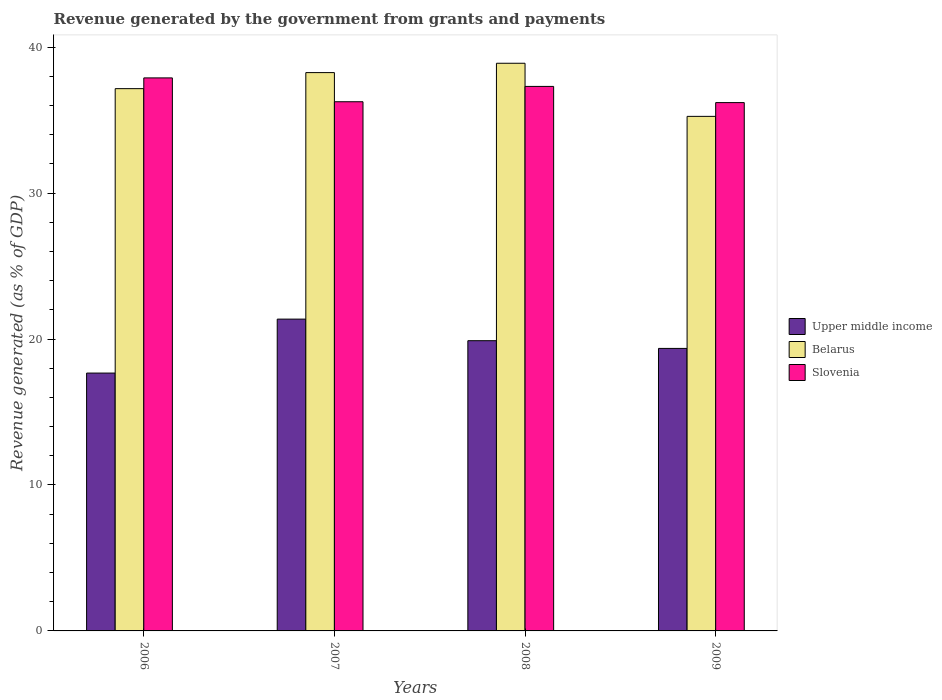Are the number of bars per tick equal to the number of legend labels?
Offer a terse response. Yes. How many bars are there on the 3rd tick from the left?
Offer a terse response. 3. In how many cases, is the number of bars for a given year not equal to the number of legend labels?
Provide a succinct answer. 0. What is the revenue generated by the government in Belarus in 2006?
Make the answer very short. 37.15. Across all years, what is the maximum revenue generated by the government in Belarus?
Ensure brevity in your answer.  38.89. Across all years, what is the minimum revenue generated by the government in Slovenia?
Offer a terse response. 36.2. In which year was the revenue generated by the government in Upper middle income maximum?
Offer a very short reply. 2007. In which year was the revenue generated by the government in Slovenia minimum?
Offer a terse response. 2009. What is the total revenue generated by the government in Upper middle income in the graph?
Offer a very short reply. 78.27. What is the difference between the revenue generated by the government in Upper middle income in 2006 and that in 2009?
Your answer should be compact. -1.69. What is the difference between the revenue generated by the government in Belarus in 2007 and the revenue generated by the government in Upper middle income in 2009?
Ensure brevity in your answer.  18.9. What is the average revenue generated by the government in Upper middle income per year?
Your answer should be very brief. 19.57. In the year 2006, what is the difference between the revenue generated by the government in Belarus and revenue generated by the government in Upper middle income?
Your response must be concise. 19.49. What is the ratio of the revenue generated by the government in Belarus in 2007 to that in 2008?
Give a very brief answer. 0.98. What is the difference between the highest and the second highest revenue generated by the government in Belarus?
Ensure brevity in your answer.  0.64. What is the difference between the highest and the lowest revenue generated by the government in Slovenia?
Offer a terse response. 1.69. Is the sum of the revenue generated by the government in Upper middle income in 2006 and 2009 greater than the maximum revenue generated by the government in Slovenia across all years?
Provide a succinct answer. No. What does the 3rd bar from the left in 2008 represents?
Provide a succinct answer. Slovenia. What does the 2nd bar from the right in 2006 represents?
Provide a short and direct response. Belarus. Is it the case that in every year, the sum of the revenue generated by the government in Upper middle income and revenue generated by the government in Slovenia is greater than the revenue generated by the government in Belarus?
Keep it short and to the point. Yes. How many bars are there?
Your answer should be very brief. 12. How many years are there in the graph?
Provide a succinct answer. 4. Does the graph contain any zero values?
Make the answer very short. No. Where does the legend appear in the graph?
Your answer should be compact. Center right. How many legend labels are there?
Make the answer very short. 3. How are the legend labels stacked?
Provide a succinct answer. Vertical. What is the title of the graph?
Provide a short and direct response. Revenue generated by the government from grants and payments. Does "Ethiopia" appear as one of the legend labels in the graph?
Offer a terse response. No. What is the label or title of the X-axis?
Give a very brief answer. Years. What is the label or title of the Y-axis?
Your answer should be compact. Revenue generated (as % of GDP). What is the Revenue generated (as % of GDP) in Upper middle income in 2006?
Provide a short and direct response. 17.67. What is the Revenue generated (as % of GDP) of Belarus in 2006?
Keep it short and to the point. 37.15. What is the Revenue generated (as % of GDP) of Slovenia in 2006?
Provide a succinct answer. 37.89. What is the Revenue generated (as % of GDP) of Upper middle income in 2007?
Offer a very short reply. 21.36. What is the Revenue generated (as % of GDP) of Belarus in 2007?
Your answer should be very brief. 38.25. What is the Revenue generated (as % of GDP) in Slovenia in 2007?
Offer a terse response. 36.25. What is the Revenue generated (as % of GDP) of Upper middle income in 2008?
Keep it short and to the point. 19.88. What is the Revenue generated (as % of GDP) in Belarus in 2008?
Your response must be concise. 38.89. What is the Revenue generated (as % of GDP) of Slovenia in 2008?
Your response must be concise. 37.31. What is the Revenue generated (as % of GDP) in Upper middle income in 2009?
Provide a succinct answer. 19.35. What is the Revenue generated (as % of GDP) of Belarus in 2009?
Offer a terse response. 35.25. What is the Revenue generated (as % of GDP) in Slovenia in 2009?
Your answer should be very brief. 36.2. Across all years, what is the maximum Revenue generated (as % of GDP) in Upper middle income?
Your response must be concise. 21.36. Across all years, what is the maximum Revenue generated (as % of GDP) in Belarus?
Ensure brevity in your answer.  38.89. Across all years, what is the maximum Revenue generated (as % of GDP) of Slovenia?
Provide a short and direct response. 37.89. Across all years, what is the minimum Revenue generated (as % of GDP) in Upper middle income?
Your answer should be compact. 17.67. Across all years, what is the minimum Revenue generated (as % of GDP) of Belarus?
Keep it short and to the point. 35.25. Across all years, what is the minimum Revenue generated (as % of GDP) of Slovenia?
Your answer should be compact. 36.2. What is the total Revenue generated (as % of GDP) of Upper middle income in the graph?
Keep it short and to the point. 78.27. What is the total Revenue generated (as % of GDP) in Belarus in the graph?
Provide a short and direct response. 149.55. What is the total Revenue generated (as % of GDP) of Slovenia in the graph?
Your answer should be compact. 147.64. What is the difference between the Revenue generated (as % of GDP) of Upper middle income in 2006 and that in 2007?
Provide a succinct answer. -3.7. What is the difference between the Revenue generated (as % of GDP) of Belarus in 2006 and that in 2007?
Your answer should be very brief. -1.1. What is the difference between the Revenue generated (as % of GDP) in Slovenia in 2006 and that in 2007?
Provide a short and direct response. 1.63. What is the difference between the Revenue generated (as % of GDP) in Upper middle income in 2006 and that in 2008?
Ensure brevity in your answer.  -2.22. What is the difference between the Revenue generated (as % of GDP) of Belarus in 2006 and that in 2008?
Offer a very short reply. -1.74. What is the difference between the Revenue generated (as % of GDP) of Slovenia in 2006 and that in 2008?
Keep it short and to the point. 0.58. What is the difference between the Revenue generated (as % of GDP) of Upper middle income in 2006 and that in 2009?
Provide a short and direct response. -1.69. What is the difference between the Revenue generated (as % of GDP) in Belarus in 2006 and that in 2009?
Your answer should be compact. 1.9. What is the difference between the Revenue generated (as % of GDP) in Slovenia in 2006 and that in 2009?
Your answer should be compact. 1.69. What is the difference between the Revenue generated (as % of GDP) in Upper middle income in 2007 and that in 2008?
Your answer should be compact. 1.48. What is the difference between the Revenue generated (as % of GDP) in Belarus in 2007 and that in 2008?
Your response must be concise. -0.64. What is the difference between the Revenue generated (as % of GDP) of Slovenia in 2007 and that in 2008?
Offer a very short reply. -1.05. What is the difference between the Revenue generated (as % of GDP) of Upper middle income in 2007 and that in 2009?
Your answer should be compact. 2.01. What is the difference between the Revenue generated (as % of GDP) of Belarus in 2007 and that in 2009?
Your answer should be compact. 3. What is the difference between the Revenue generated (as % of GDP) of Slovenia in 2007 and that in 2009?
Give a very brief answer. 0.06. What is the difference between the Revenue generated (as % of GDP) of Upper middle income in 2008 and that in 2009?
Your response must be concise. 0.53. What is the difference between the Revenue generated (as % of GDP) of Belarus in 2008 and that in 2009?
Keep it short and to the point. 3.64. What is the difference between the Revenue generated (as % of GDP) of Slovenia in 2008 and that in 2009?
Give a very brief answer. 1.11. What is the difference between the Revenue generated (as % of GDP) of Upper middle income in 2006 and the Revenue generated (as % of GDP) of Belarus in 2007?
Ensure brevity in your answer.  -20.59. What is the difference between the Revenue generated (as % of GDP) in Upper middle income in 2006 and the Revenue generated (as % of GDP) in Slovenia in 2007?
Offer a very short reply. -18.59. What is the difference between the Revenue generated (as % of GDP) in Belarus in 2006 and the Revenue generated (as % of GDP) in Slovenia in 2007?
Provide a short and direct response. 0.9. What is the difference between the Revenue generated (as % of GDP) of Upper middle income in 2006 and the Revenue generated (as % of GDP) of Belarus in 2008?
Provide a short and direct response. -21.23. What is the difference between the Revenue generated (as % of GDP) in Upper middle income in 2006 and the Revenue generated (as % of GDP) in Slovenia in 2008?
Offer a terse response. -19.64. What is the difference between the Revenue generated (as % of GDP) of Belarus in 2006 and the Revenue generated (as % of GDP) of Slovenia in 2008?
Your answer should be compact. -0.15. What is the difference between the Revenue generated (as % of GDP) of Upper middle income in 2006 and the Revenue generated (as % of GDP) of Belarus in 2009?
Offer a terse response. -17.59. What is the difference between the Revenue generated (as % of GDP) in Upper middle income in 2006 and the Revenue generated (as % of GDP) in Slovenia in 2009?
Provide a short and direct response. -18.53. What is the difference between the Revenue generated (as % of GDP) in Belarus in 2006 and the Revenue generated (as % of GDP) in Slovenia in 2009?
Provide a short and direct response. 0.96. What is the difference between the Revenue generated (as % of GDP) in Upper middle income in 2007 and the Revenue generated (as % of GDP) in Belarus in 2008?
Provide a succinct answer. -17.53. What is the difference between the Revenue generated (as % of GDP) of Upper middle income in 2007 and the Revenue generated (as % of GDP) of Slovenia in 2008?
Keep it short and to the point. -15.94. What is the difference between the Revenue generated (as % of GDP) in Belarus in 2007 and the Revenue generated (as % of GDP) in Slovenia in 2008?
Ensure brevity in your answer.  0.95. What is the difference between the Revenue generated (as % of GDP) of Upper middle income in 2007 and the Revenue generated (as % of GDP) of Belarus in 2009?
Ensure brevity in your answer.  -13.89. What is the difference between the Revenue generated (as % of GDP) in Upper middle income in 2007 and the Revenue generated (as % of GDP) in Slovenia in 2009?
Provide a short and direct response. -14.83. What is the difference between the Revenue generated (as % of GDP) of Belarus in 2007 and the Revenue generated (as % of GDP) of Slovenia in 2009?
Your answer should be very brief. 2.06. What is the difference between the Revenue generated (as % of GDP) of Upper middle income in 2008 and the Revenue generated (as % of GDP) of Belarus in 2009?
Offer a very short reply. -15.37. What is the difference between the Revenue generated (as % of GDP) of Upper middle income in 2008 and the Revenue generated (as % of GDP) of Slovenia in 2009?
Your answer should be compact. -16.31. What is the difference between the Revenue generated (as % of GDP) of Belarus in 2008 and the Revenue generated (as % of GDP) of Slovenia in 2009?
Make the answer very short. 2.7. What is the average Revenue generated (as % of GDP) of Upper middle income per year?
Offer a very short reply. 19.57. What is the average Revenue generated (as % of GDP) of Belarus per year?
Keep it short and to the point. 37.39. What is the average Revenue generated (as % of GDP) in Slovenia per year?
Offer a terse response. 36.91. In the year 2006, what is the difference between the Revenue generated (as % of GDP) in Upper middle income and Revenue generated (as % of GDP) in Belarus?
Provide a succinct answer. -19.49. In the year 2006, what is the difference between the Revenue generated (as % of GDP) in Upper middle income and Revenue generated (as % of GDP) in Slovenia?
Provide a succinct answer. -20.22. In the year 2006, what is the difference between the Revenue generated (as % of GDP) in Belarus and Revenue generated (as % of GDP) in Slovenia?
Offer a terse response. -0.74. In the year 2007, what is the difference between the Revenue generated (as % of GDP) in Upper middle income and Revenue generated (as % of GDP) in Belarus?
Your answer should be very brief. -16.89. In the year 2007, what is the difference between the Revenue generated (as % of GDP) in Upper middle income and Revenue generated (as % of GDP) in Slovenia?
Keep it short and to the point. -14.89. In the year 2007, what is the difference between the Revenue generated (as % of GDP) of Belarus and Revenue generated (as % of GDP) of Slovenia?
Offer a very short reply. 2. In the year 2008, what is the difference between the Revenue generated (as % of GDP) of Upper middle income and Revenue generated (as % of GDP) of Belarus?
Offer a very short reply. -19.01. In the year 2008, what is the difference between the Revenue generated (as % of GDP) of Upper middle income and Revenue generated (as % of GDP) of Slovenia?
Make the answer very short. -17.42. In the year 2008, what is the difference between the Revenue generated (as % of GDP) in Belarus and Revenue generated (as % of GDP) in Slovenia?
Keep it short and to the point. 1.59. In the year 2009, what is the difference between the Revenue generated (as % of GDP) in Upper middle income and Revenue generated (as % of GDP) in Belarus?
Ensure brevity in your answer.  -15.9. In the year 2009, what is the difference between the Revenue generated (as % of GDP) in Upper middle income and Revenue generated (as % of GDP) in Slovenia?
Your answer should be very brief. -16.84. In the year 2009, what is the difference between the Revenue generated (as % of GDP) in Belarus and Revenue generated (as % of GDP) in Slovenia?
Offer a terse response. -0.94. What is the ratio of the Revenue generated (as % of GDP) in Upper middle income in 2006 to that in 2007?
Provide a succinct answer. 0.83. What is the ratio of the Revenue generated (as % of GDP) in Belarus in 2006 to that in 2007?
Provide a short and direct response. 0.97. What is the ratio of the Revenue generated (as % of GDP) of Slovenia in 2006 to that in 2007?
Keep it short and to the point. 1.05. What is the ratio of the Revenue generated (as % of GDP) in Upper middle income in 2006 to that in 2008?
Offer a very short reply. 0.89. What is the ratio of the Revenue generated (as % of GDP) in Belarus in 2006 to that in 2008?
Keep it short and to the point. 0.96. What is the ratio of the Revenue generated (as % of GDP) of Slovenia in 2006 to that in 2008?
Ensure brevity in your answer.  1.02. What is the ratio of the Revenue generated (as % of GDP) of Upper middle income in 2006 to that in 2009?
Keep it short and to the point. 0.91. What is the ratio of the Revenue generated (as % of GDP) of Belarus in 2006 to that in 2009?
Keep it short and to the point. 1.05. What is the ratio of the Revenue generated (as % of GDP) of Slovenia in 2006 to that in 2009?
Your answer should be very brief. 1.05. What is the ratio of the Revenue generated (as % of GDP) in Upper middle income in 2007 to that in 2008?
Keep it short and to the point. 1.07. What is the ratio of the Revenue generated (as % of GDP) in Belarus in 2007 to that in 2008?
Offer a terse response. 0.98. What is the ratio of the Revenue generated (as % of GDP) of Slovenia in 2007 to that in 2008?
Offer a very short reply. 0.97. What is the ratio of the Revenue generated (as % of GDP) of Upper middle income in 2007 to that in 2009?
Provide a short and direct response. 1.1. What is the ratio of the Revenue generated (as % of GDP) of Belarus in 2007 to that in 2009?
Give a very brief answer. 1.09. What is the ratio of the Revenue generated (as % of GDP) in Upper middle income in 2008 to that in 2009?
Give a very brief answer. 1.03. What is the ratio of the Revenue generated (as % of GDP) in Belarus in 2008 to that in 2009?
Your answer should be compact. 1.1. What is the ratio of the Revenue generated (as % of GDP) in Slovenia in 2008 to that in 2009?
Give a very brief answer. 1.03. What is the difference between the highest and the second highest Revenue generated (as % of GDP) of Upper middle income?
Offer a terse response. 1.48. What is the difference between the highest and the second highest Revenue generated (as % of GDP) in Belarus?
Offer a terse response. 0.64. What is the difference between the highest and the second highest Revenue generated (as % of GDP) in Slovenia?
Offer a very short reply. 0.58. What is the difference between the highest and the lowest Revenue generated (as % of GDP) in Upper middle income?
Ensure brevity in your answer.  3.7. What is the difference between the highest and the lowest Revenue generated (as % of GDP) of Belarus?
Offer a very short reply. 3.64. What is the difference between the highest and the lowest Revenue generated (as % of GDP) of Slovenia?
Make the answer very short. 1.69. 